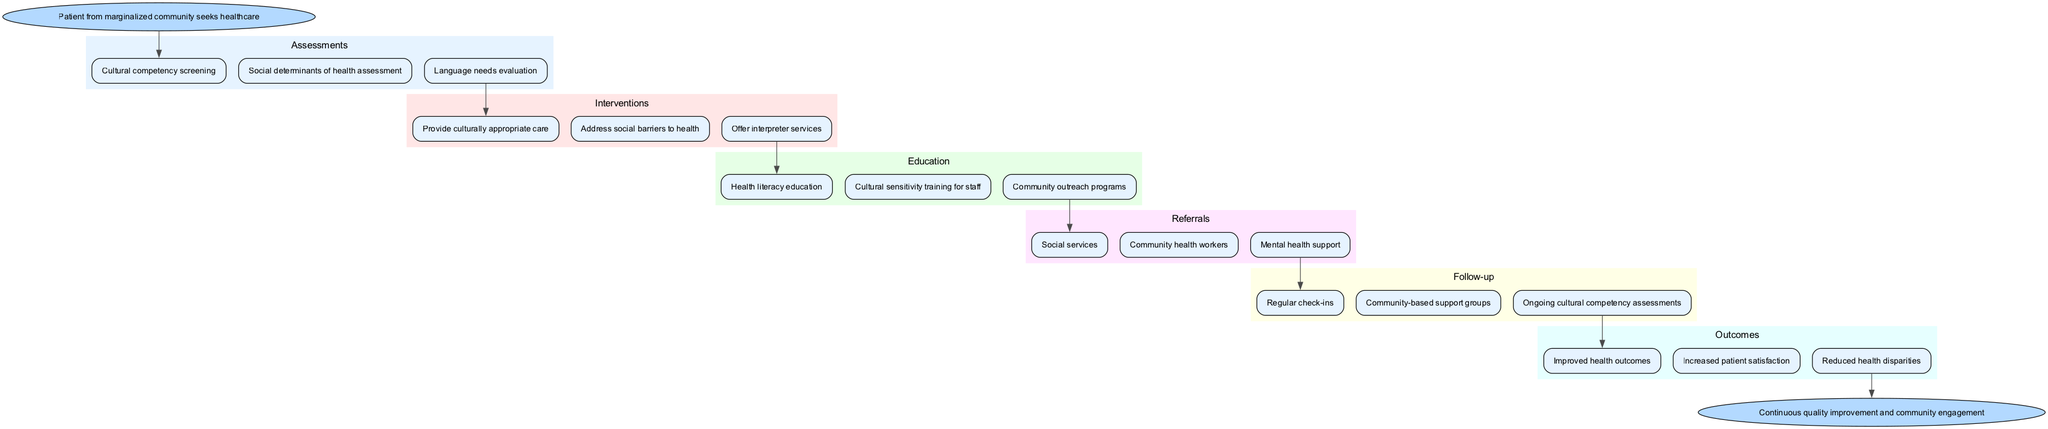What is the starting point of the clinical pathway? The start node indicates that the clinical pathway begins with a patient from a marginalized community seeking healthcare.
Answer: Patient from marginalized community seeks healthcare How many assessments are there in the pathway? By counting the nodes under the assessments section, there are three assessments listed in total.
Answer: 3 What is the first intervention listed in the diagram? The interventions are categorized and the first node under interventions describes the provision of culturally appropriate care.
Answer: Provide culturally appropriate care Which node follows the "Language needs evaluation" assessment? The edge from the "Language needs evaluation" connects directly to the first intervention node, which is "Provide culturally appropriate care".
Answer: Provide culturally appropriate care What outcomes are expected after following the pathway? The outcomes section lists three results, of which the first one is "Improved health outcomes".
Answer: Improved health outcomes What type of education is included in the pathway? The education section indicates three areas of focus, with the first being health literacy education.
Answer: Health literacy education How does the pathway address social barriers to health? The diagram indicates that addressing social barriers is part of the intervention phase, specifically listed as "Address social barriers to health".
Answer: Address social barriers to health What follows the "Ongoing cultural competency assessments" in the follow-up section? The follow-up section has multiple outcomes, and the last node points to "Continuous quality improvement and community engagement" as the endpoint.
Answer: Continuous quality improvement and community engagement How many referral options are listed in the pathway? There are three referral options enumerated under the referrals section, indicating the available services.
Answer: 3 